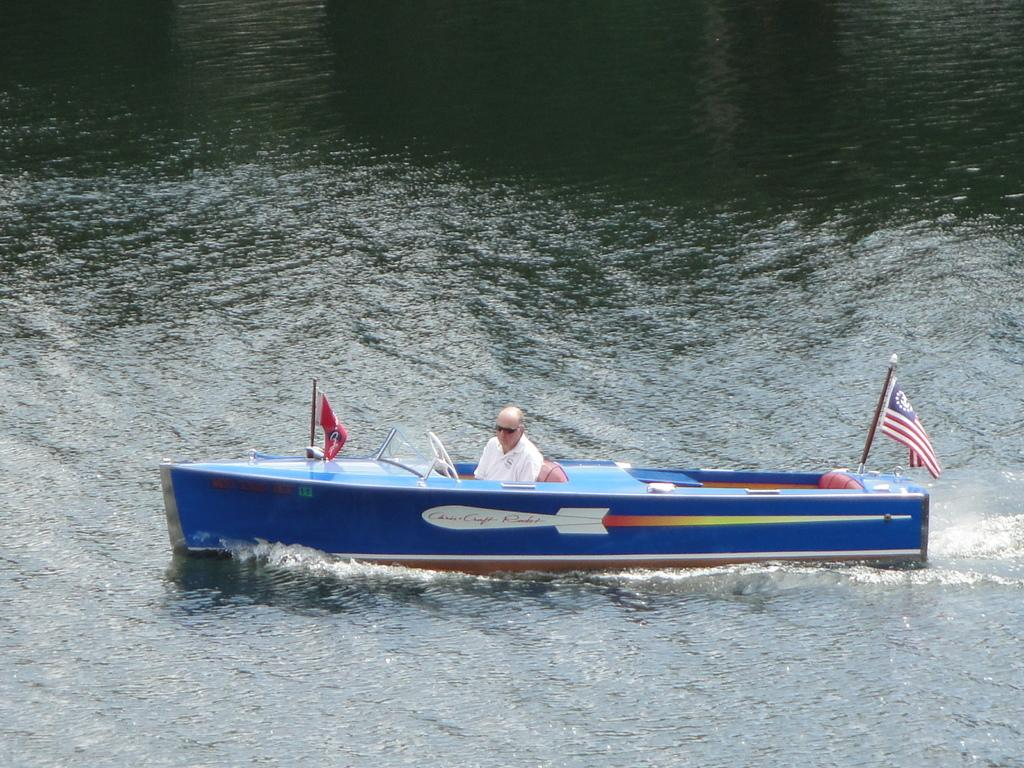Who is the main subject in the image? There is a man in the image. What is the man doing in the image? The man is sailing a boat. Where is the boat located in the image? The boat is in the water. What decorative elements are attached to the boat? There are flags attached to the boat. What type of meat is being cooked on the ground in the image? There is no meat or cooking activity present in the image; it features a man sailing a boat in the water. 